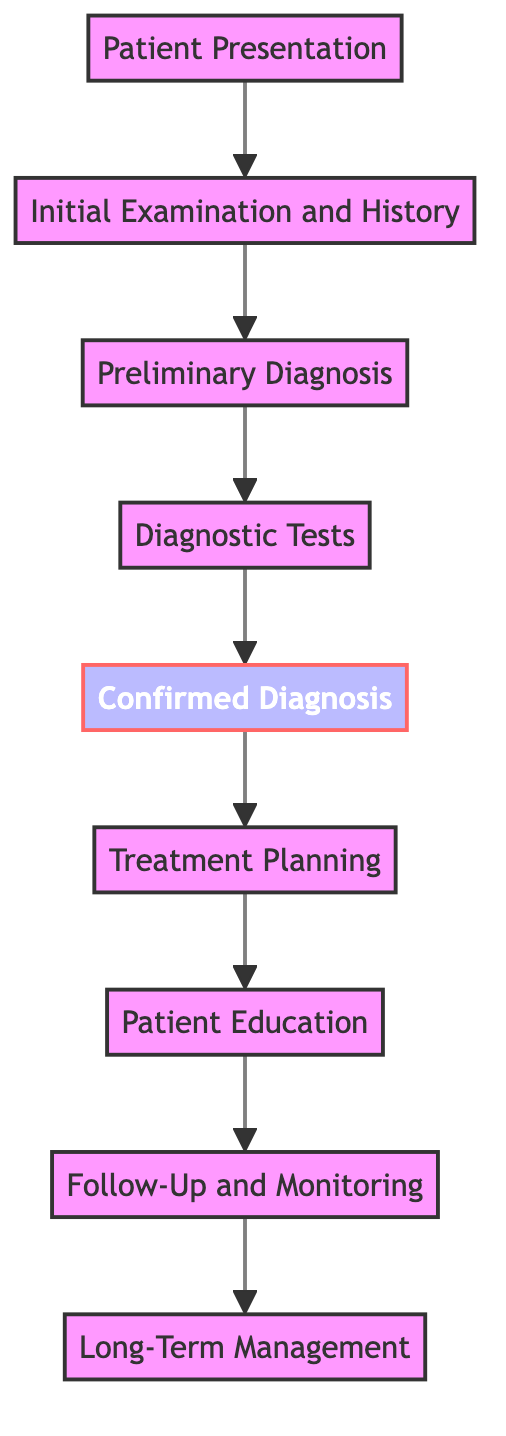What is the first step in the pathway? The first step in the pathway is "Patient Presentation," which refers to patients visiting with initial symptoms such as rash, itchiness, or redness.
Answer: Patient Presentation How many total nodes are in the diagram? By counting each distinct box in the diagram, there are a total of 9 nodes, from "Patient Presentation" to "Long-Term Management."
Answer: 9 Which node follows "Diagnostic Tests"? After "Diagnostic Tests," the next node is "Confirmed Diagnosis," which signifies interpreting test results to confirm the exact skin condition.
Answer: Confirmed Diagnosis What is the last node in the pathway? The last node in the pathway, representing the final step, is "Long-Term Management," which focuses on maintaining skin health and preventing recurrences.
Answer: Long-Term Management Which step requires interpretation of test results? The step that requires interpretation of test results is "Confirmed Diagnosis," where the specific skin condition is confirmed based on diagnostic tests.
Answer: Confirmed Diagnosis What comes before "Treatment Planning"? Before "Treatment Planning," the step is "Confirmed Diagnosis," indicating that a diagnosis must be confirmed prior to devising a personalized treatment plan.
Answer: Confirmed Diagnosis How many steps involve patient education? There is one step specifically focused on patient education, which is "Patient Education," aimed at informing the patient about their condition and treatment plan.
Answer: 1 What is the connection between "Follow-Up and Monitoring" and "Long-Term Management"? "Follow-Up and Monitoring" leads directly into "Long-Term Management," signifying that ongoing monitoring is essential for effective long-term care of skin health.
Answer: Direct connection What type of tests are conducted at the "Diagnostic Tests" step? At the "Diagnostic Tests" step, necessary tests include skin biopsy, allergy testing, and blood tests to confirm the diagnosis.
Answer: Skin biopsy, allergy testing, blood tests 